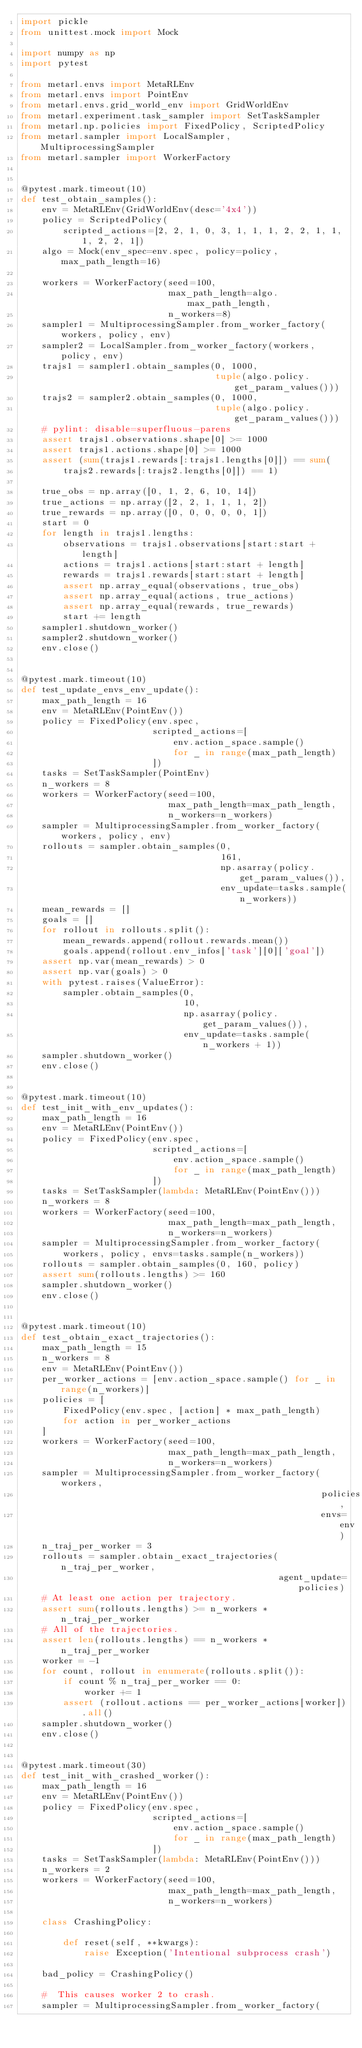<code> <loc_0><loc_0><loc_500><loc_500><_Python_>import pickle
from unittest.mock import Mock

import numpy as np
import pytest

from metarl.envs import MetaRLEnv
from metarl.envs import PointEnv
from metarl.envs.grid_world_env import GridWorldEnv
from metarl.experiment.task_sampler import SetTaskSampler
from metarl.np.policies import FixedPolicy, ScriptedPolicy
from metarl.sampler import LocalSampler, MultiprocessingSampler
from metarl.sampler import WorkerFactory


@pytest.mark.timeout(10)
def test_obtain_samples():
    env = MetaRLEnv(GridWorldEnv(desc='4x4'))
    policy = ScriptedPolicy(
        scripted_actions=[2, 2, 1, 0, 3, 1, 1, 1, 2, 2, 1, 1, 1, 2, 2, 1])
    algo = Mock(env_spec=env.spec, policy=policy, max_path_length=16)

    workers = WorkerFactory(seed=100,
                            max_path_length=algo.max_path_length,
                            n_workers=8)
    sampler1 = MultiprocessingSampler.from_worker_factory(workers, policy, env)
    sampler2 = LocalSampler.from_worker_factory(workers, policy, env)
    trajs1 = sampler1.obtain_samples(0, 1000,
                                     tuple(algo.policy.get_param_values()))
    trajs2 = sampler2.obtain_samples(0, 1000,
                                     tuple(algo.policy.get_param_values()))
    # pylint: disable=superfluous-parens
    assert trajs1.observations.shape[0] >= 1000
    assert trajs1.actions.shape[0] >= 1000
    assert (sum(trajs1.rewards[:trajs1.lengths[0]]) == sum(
        trajs2.rewards[:trajs2.lengths[0]]) == 1)

    true_obs = np.array([0, 1, 2, 6, 10, 14])
    true_actions = np.array([2, 2, 1, 1, 1, 2])
    true_rewards = np.array([0, 0, 0, 0, 0, 1])
    start = 0
    for length in trajs1.lengths:
        observations = trajs1.observations[start:start + length]
        actions = trajs1.actions[start:start + length]
        rewards = trajs1.rewards[start:start + length]
        assert np.array_equal(observations, true_obs)
        assert np.array_equal(actions, true_actions)
        assert np.array_equal(rewards, true_rewards)
        start += length
    sampler1.shutdown_worker()
    sampler2.shutdown_worker()
    env.close()


@pytest.mark.timeout(10)
def test_update_envs_env_update():
    max_path_length = 16
    env = MetaRLEnv(PointEnv())
    policy = FixedPolicy(env.spec,
                         scripted_actions=[
                             env.action_space.sample()
                             for _ in range(max_path_length)
                         ])
    tasks = SetTaskSampler(PointEnv)
    n_workers = 8
    workers = WorkerFactory(seed=100,
                            max_path_length=max_path_length,
                            n_workers=n_workers)
    sampler = MultiprocessingSampler.from_worker_factory(workers, policy, env)
    rollouts = sampler.obtain_samples(0,
                                      161,
                                      np.asarray(policy.get_param_values()),
                                      env_update=tasks.sample(n_workers))
    mean_rewards = []
    goals = []
    for rollout in rollouts.split():
        mean_rewards.append(rollout.rewards.mean())
        goals.append(rollout.env_infos['task'][0]['goal'])
    assert np.var(mean_rewards) > 0
    assert np.var(goals) > 0
    with pytest.raises(ValueError):
        sampler.obtain_samples(0,
                               10,
                               np.asarray(policy.get_param_values()),
                               env_update=tasks.sample(n_workers + 1))
    sampler.shutdown_worker()
    env.close()


@pytest.mark.timeout(10)
def test_init_with_env_updates():
    max_path_length = 16
    env = MetaRLEnv(PointEnv())
    policy = FixedPolicy(env.spec,
                         scripted_actions=[
                             env.action_space.sample()
                             for _ in range(max_path_length)
                         ])
    tasks = SetTaskSampler(lambda: MetaRLEnv(PointEnv()))
    n_workers = 8
    workers = WorkerFactory(seed=100,
                            max_path_length=max_path_length,
                            n_workers=n_workers)
    sampler = MultiprocessingSampler.from_worker_factory(
        workers, policy, envs=tasks.sample(n_workers))
    rollouts = sampler.obtain_samples(0, 160, policy)
    assert sum(rollouts.lengths) >= 160
    sampler.shutdown_worker()
    env.close()


@pytest.mark.timeout(10)
def test_obtain_exact_trajectories():
    max_path_length = 15
    n_workers = 8
    env = MetaRLEnv(PointEnv())
    per_worker_actions = [env.action_space.sample() for _ in range(n_workers)]
    policies = [
        FixedPolicy(env.spec, [action] * max_path_length)
        for action in per_worker_actions
    ]
    workers = WorkerFactory(seed=100,
                            max_path_length=max_path_length,
                            n_workers=n_workers)
    sampler = MultiprocessingSampler.from_worker_factory(workers,
                                                         policies,
                                                         envs=env)
    n_traj_per_worker = 3
    rollouts = sampler.obtain_exact_trajectories(n_traj_per_worker,
                                                 agent_update=policies)
    # At least one action per trajectory.
    assert sum(rollouts.lengths) >= n_workers * n_traj_per_worker
    # All of the trajectories.
    assert len(rollouts.lengths) == n_workers * n_traj_per_worker
    worker = -1
    for count, rollout in enumerate(rollouts.split()):
        if count % n_traj_per_worker == 0:
            worker += 1
        assert (rollout.actions == per_worker_actions[worker]).all()
    sampler.shutdown_worker()
    env.close()


@pytest.mark.timeout(30)
def test_init_with_crashed_worker():
    max_path_length = 16
    env = MetaRLEnv(PointEnv())
    policy = FixedPolicy(env.spec,
                         scripted_actions=[
                             env.action_space.sample()
                             for _ in range(max_path_length)
                         ])
    tasks = SetTaskSampler(lambda: MetaRLEnv(PointEnv()))
    n_workers = 2
    workers = WorkerFactory(seed=100,
                            max_path_length=max_path_length,
                            n_workers=n_workers)

    class CrashingPolicy:

        def reset(self, **kwargs):
            raise Exception('Intentional subprocess crash')

    bad_policy = CrashingPolicy()

    #  This causes worker 2 to crash.
    sampler = MultiprocessingSampler.from_worker_factory(</code> 